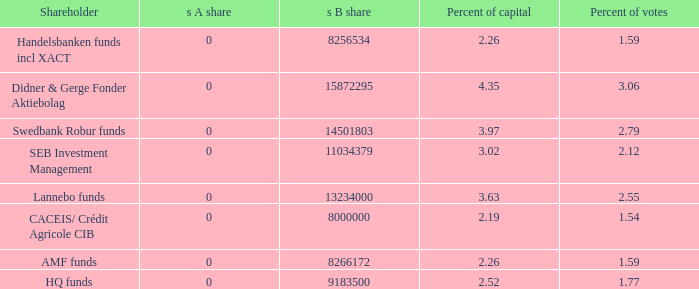What is the s B share for Handelsbanken funds incl XACT? 8256534.0. 